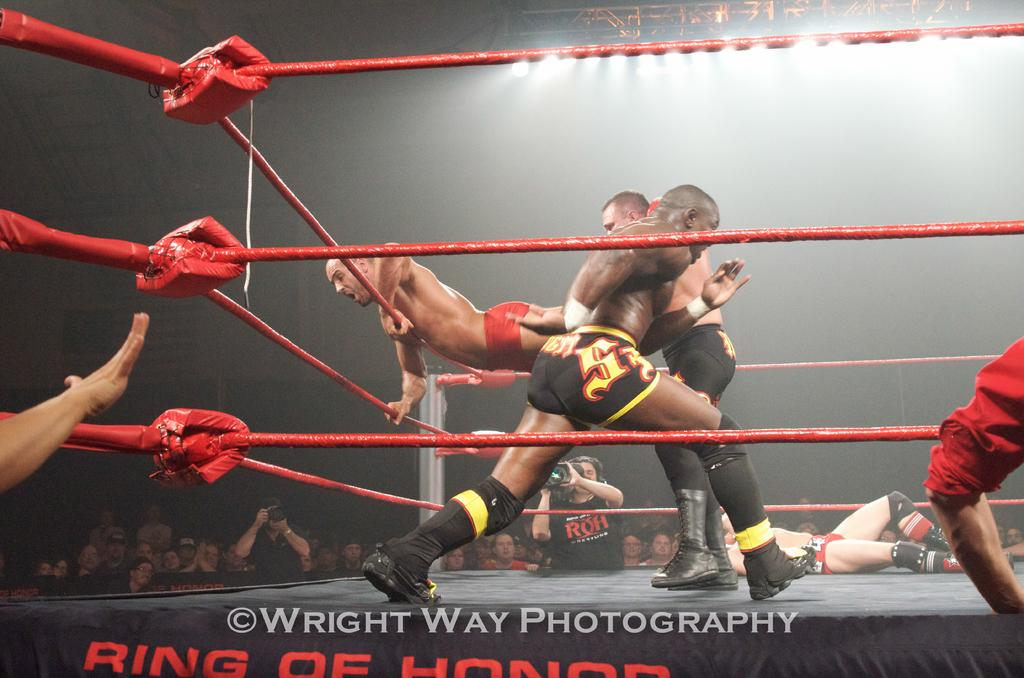What activity are the people in the image engaged in? There is a group of people playing a game in the image. Can you describe the person standing in the background? The person standing in the background is wearing a black shirt and holding a camera. What else can be seen in the background of the image? There is a group of people sitting in the background. What type of error can be seen in the image? There is no error present in the image. Can you describe the worm that is crawling on the game board? There is no worm present in the image; it is a group of people playing a game. 